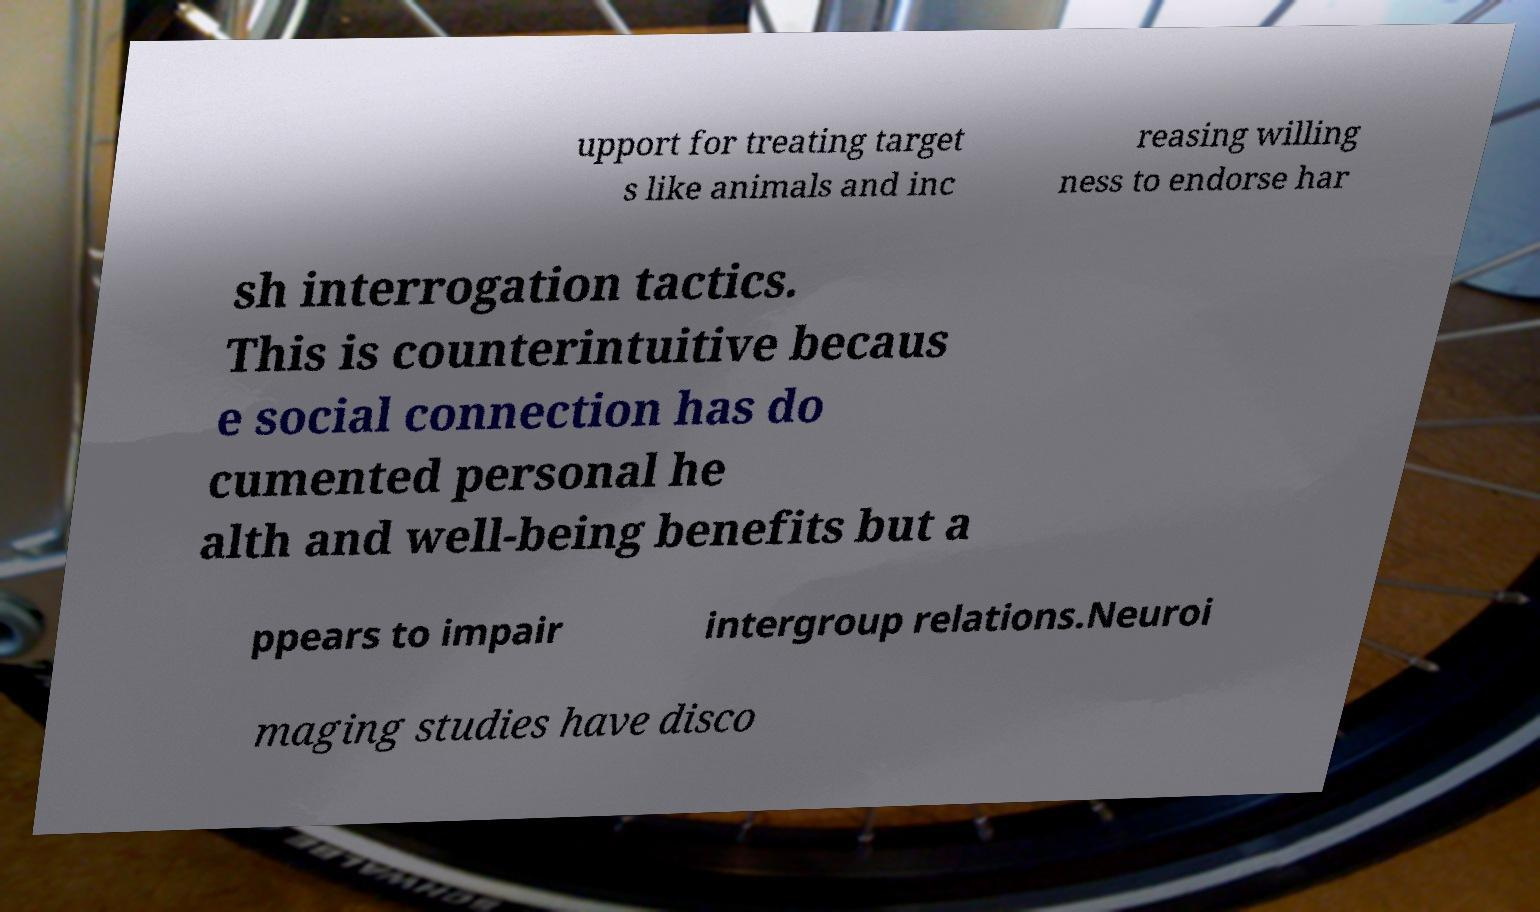Could you extract and type out the text from this image? upport for treating target s like animals and inc reasing willing ness to endorse har sh interrogation tactics. This is counterintuitive becaus e social connection has do cumented personal he alth and well-being benefits but a ppears to impair intergroup relations.Neuroi maging studies have disco 